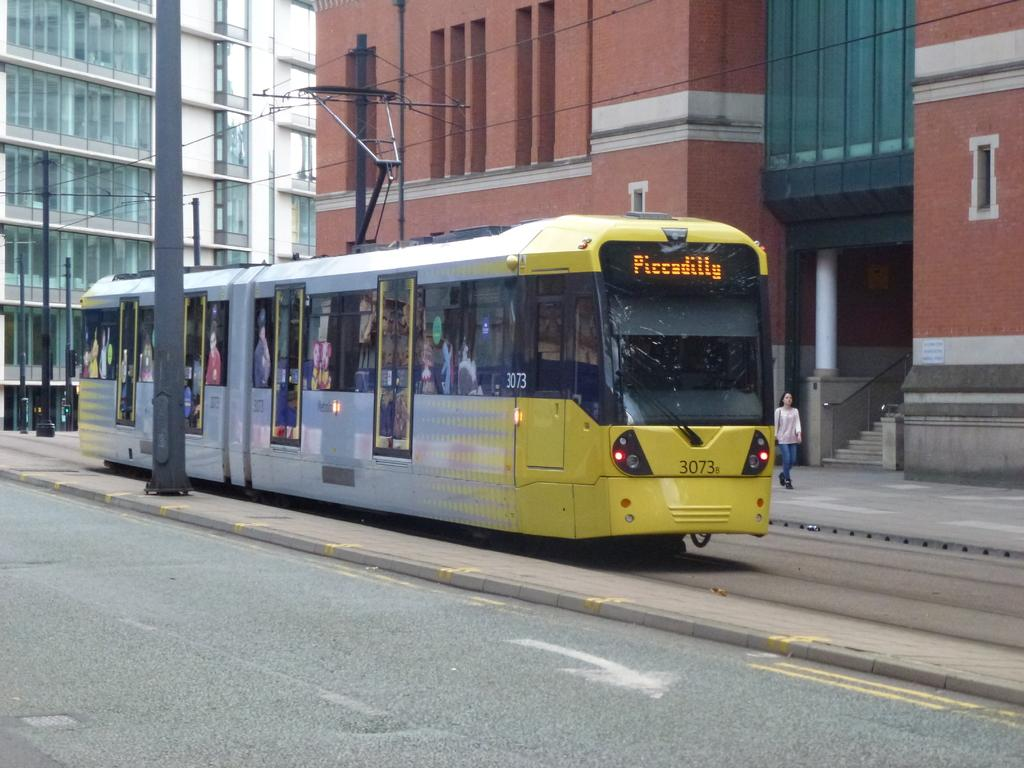What is the main subject of the image? There is a train in the image. Can you describe the train's position? The train is on a track. What else can be seen on the right side of the image? There is a woman walking on the right side of the image. What is visible in the background of the image? There is a building with a staircase and a group of poles in the background. What type of bulb is being used to light up the train in the image? There is no mention of a bulb or lighting in the image; it only shows a train on a track, a woman walking, and a background with a building and poles. 